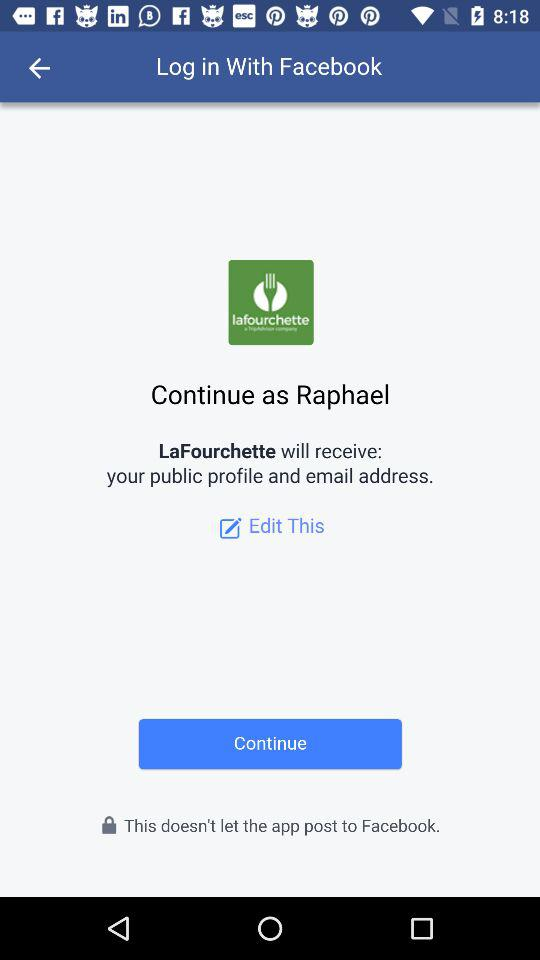What application is asking for permission? The application is "LaFourchette". 